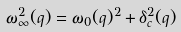Convert formula to latex. <formula><loc_0><loc_0><loc_500><loc_500>\omega ^ { 2 } _ { \infty } ( q ) = \omega _ { 0 } ( q ) ^ { 2 } + \delta _ { c } ^ { 2 } ( q )</formula> 